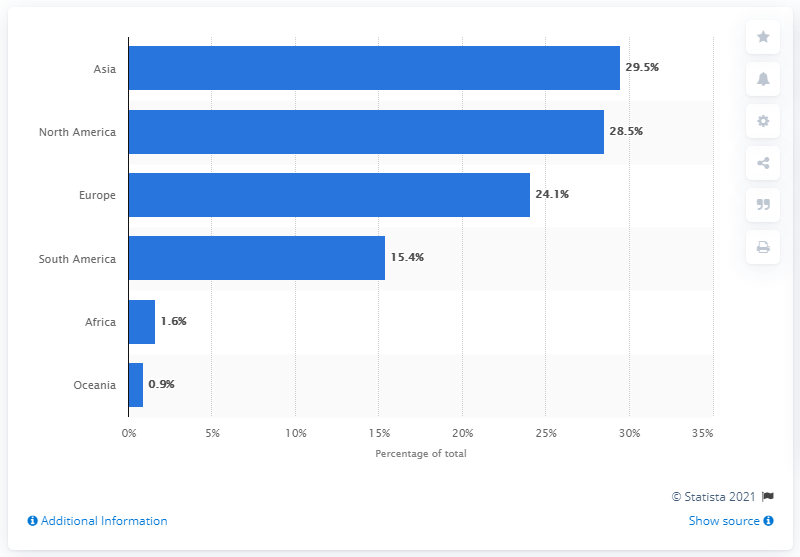Mention a couple of crucial points in this snapshot. In 2011, the majority of cosmetic procedures were performed in Asia. 